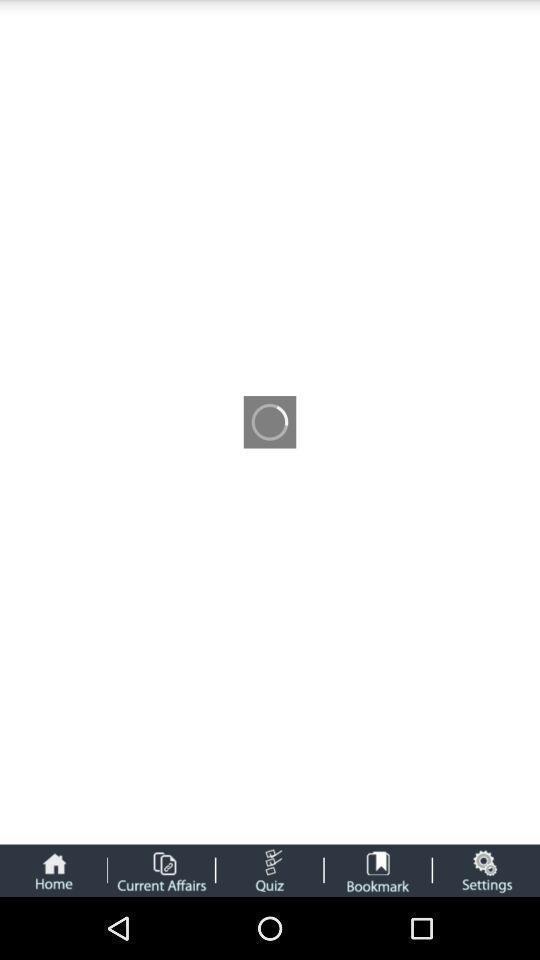Tell me what you see in this picture. Page loading in a current affairs app. 